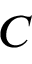<formula> <loc_0><loc_0><loc_500><loc_500>C</formula> 